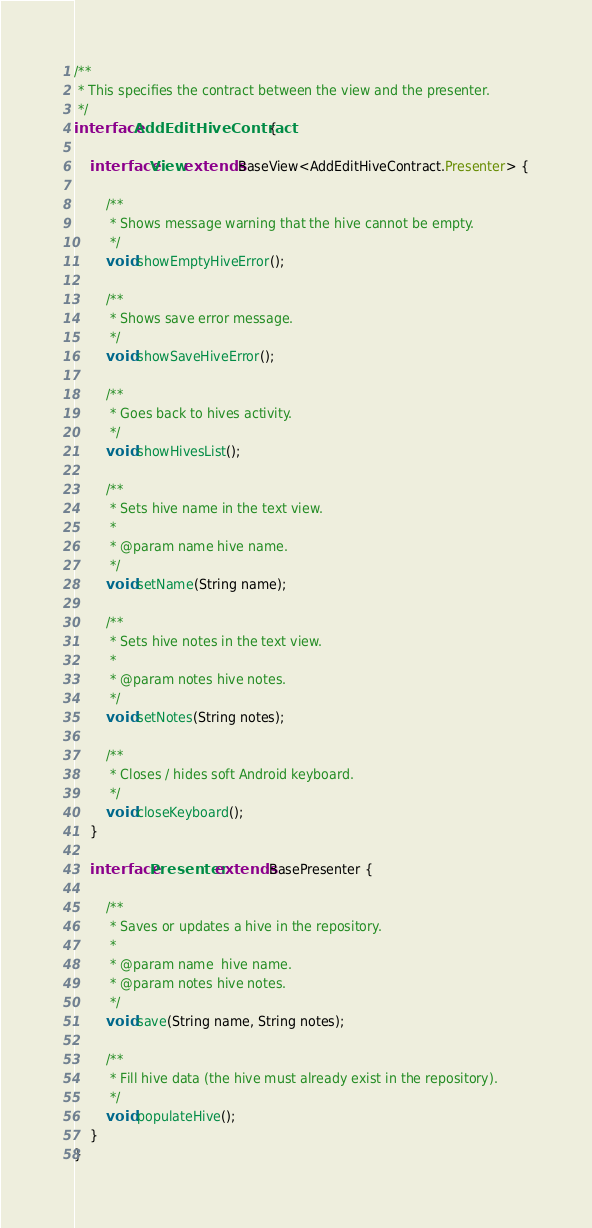Convert code to text. <code><loc_0><loc_0><loc_500><loc_500><_Java_>/**
 * This specifies the contract between the view and the presenter.
 */
interface AddEditHiveContract {

    interface View extends BaseView<AddEditHiveContract.Presenter> {

        /**
         * Shows message warning that the hive cannot be empty.
         */
        void showEmptyHiveError();

        /**
         * Shows save error message.
         */
        void showSaveHiveError();

        /**
         * Goes back to hives activity.
         */
        void showHivesList();

        /**
         * Sets hive name in the text view.
         *
         * @param name hive name.
         */
        void setName(String name);

        /**
         * Sets hive notes in the text view.
         *
         * @param notes hive notes.
         */
        void setNotes(String notes);

        /**
         * Closes / hides soft Android keyboard.
         */
        void closeKeyboard();
    }

    interface Presenter extends BasePresenter {

        /**
         * Saves or updates a hive in the repository.
         *
         * @param name  hive name.
         * @param notes hive notes.
         */
        void save(String name, String notes);

        /**
         * Fill hive data (the hive must already exist in the repository).
         */
        void populateHive();
    }
}
</code> 